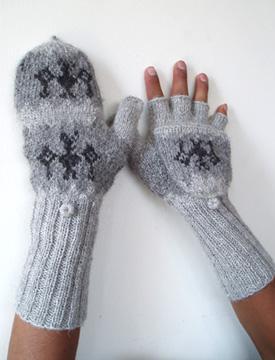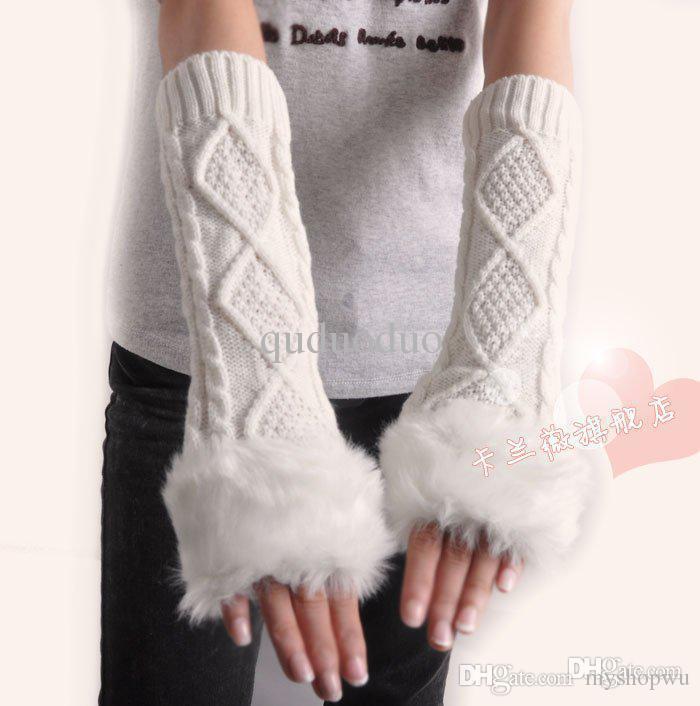The first image is the image on the left, the second image is the image on the right. Assess this claim about the two images: "The gloves in one of the images is not being worn.". Correct or not? Answer yes or no. No. The first image is the image on the left, the second image is the image on the right. For the images displayed, is the sentence "Each image shows exactly one pair of """"mittens"""", and one features a pair with a rounded flap and half-fingers." factually correct? Answer yes or no. Yes. 